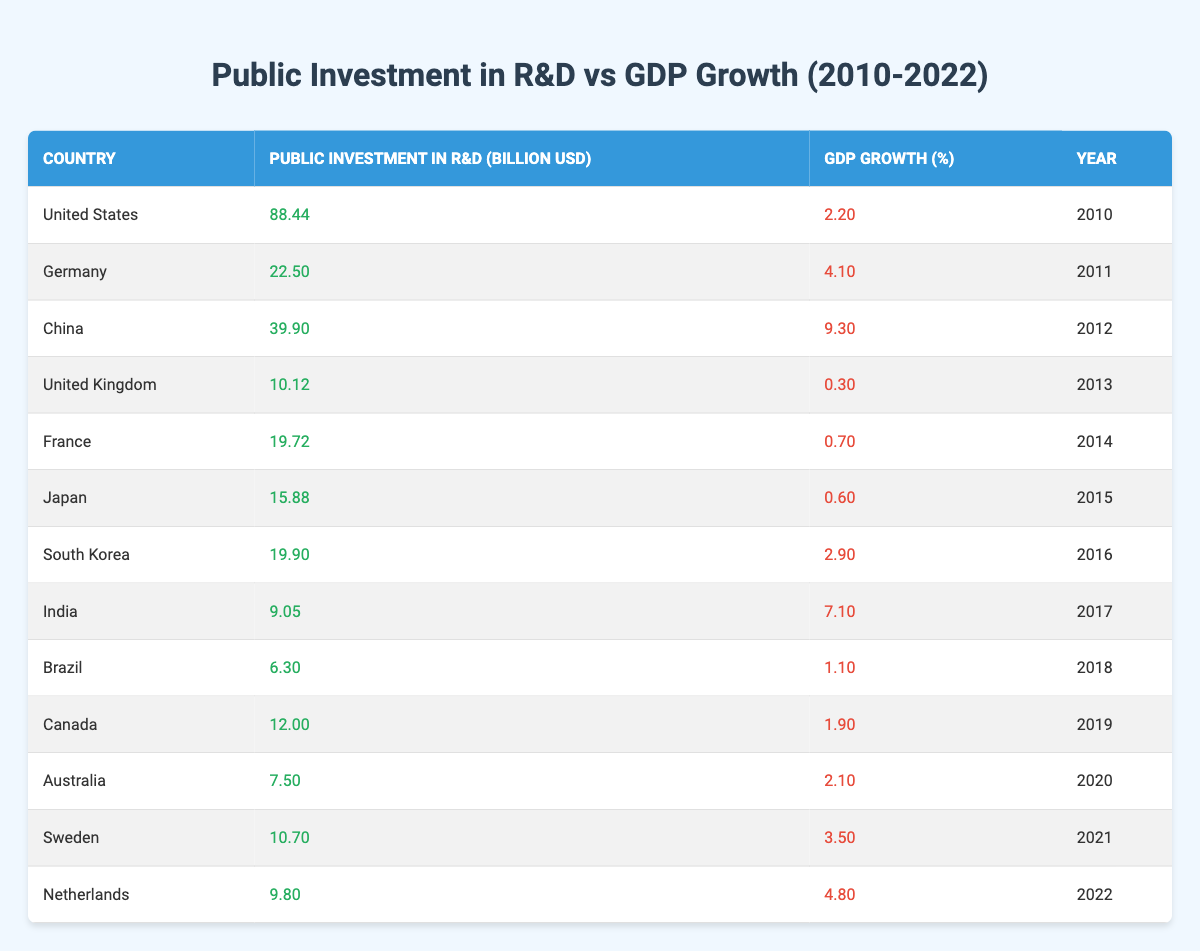What was the Public Investment in R&D for China in 2012? According to the table, China had a Public Investment in R&D of 39.90 billion USD in 2012.
Answer: 39.90 billion USD Which country had the highest GDP Growth in 2012? The table shows that China had the highest GDP Growth at 9.30% in 2012.
Answer: China What is the difference between Public Investment in R&D for the United States in 2010 and India in 2017? In 2010, the United States had a Public Investment of 88.44 billion USD, and in 2017, India had 9.05 billion USD. The difference is 88.44 - 9.05 = 79.39 billion USD.
Answer: 79.39 billion USD What was the average GDP Growth from 2010 to 2022 based on the data provided? To find the average GDP Growth, sum the GDP Growth values (2.20 + 4.10 + 9.30 + 0.30 + 0.70 + 0.60 + 2.90 + 7.10 + 1.10 + 1.90 + 2.10 + 3.50 + 4.80) which equals 36.90%, and there are 13 data points, hence the average is 36.90 / 13 ≈ 2.84%.
Answer: Approximately 2.84% Was the Public Investment in R&D for Japan higher or lower than that of Germany in 2011? In 2011, Germany's Public Investment was 22.50 billion USD, while Japan's in 2015 was 15.88 billion USD, which indicates that Japan's investment was lower than Germany's.
Answer: Lower Which country had the lowest Public Investment in R&D among the listed countries? The table indicates Brazil had the lowest Public Investment in R&D at 6.30 billion USD in 2018.
Answer: Brazil How many countries had a GDP Growth percentage greater than 4%? Reviewing the table, China (9.30%), Germany (4.10%), and the Netherlands (4.80%) had GDP Growth greater than 4%. This totals to three countries.
Answer: Three countries If we consider only the years 2010, 2011, and 2012, what is the total Public Investment in R&D by those countries? The total Public Investment in R&D is 88.44 (United States) + 22.50 (Germany) + 39.90 (China) = 150.84 billion USD.
Answer: 150.84 billion USD Which country experienced the highest GDP Growth in the post-2015 years? Looking at years after 2015 from the table, India in 2017 had the highest GDP Growth at 7.10%.
Answer: India Was there any year when the GDP Growth was below 1%? Yes, the table shows that the United Kingdom in 2013 (0.30%) and Japan in 2015 (0.60%) had GDP Growth below 1%.
Answer: Yes What trends can be inferred about the relationship between Public Investment in R&D and GDP Growth over the years? The table suggests a lack of a consistent trend; for example, high Public Investment does not always correlate with high GDP Growth as seen with the U.S. and U.K.
Answer: No consistent trend 